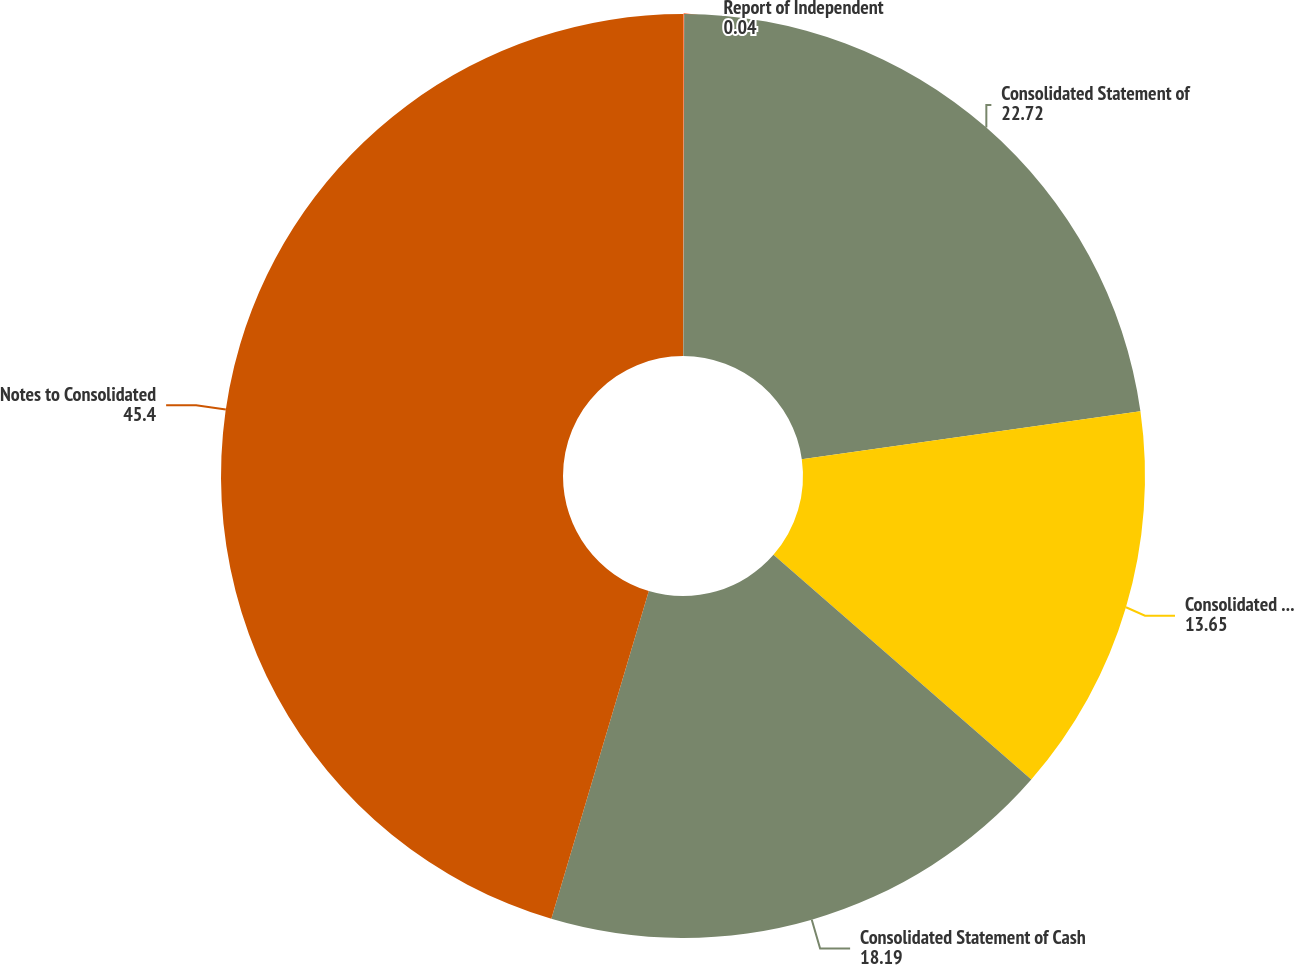Convert chart to OTSL. <chart><loc_0><loc_0><loc_500><loc_500><pie_chart><fcel>Report of Independent<fcel>Consolidated Statement of<fcel>Consolidated Balance Sheet at<fcel>Consolidated Statement of Cash<fcel>Notes to Consolidated<nl><fcel>0.04%<fcel>22.72%<fcel>13.65%<fcel>18.19%<fcel>45.4%<nl></chart> 